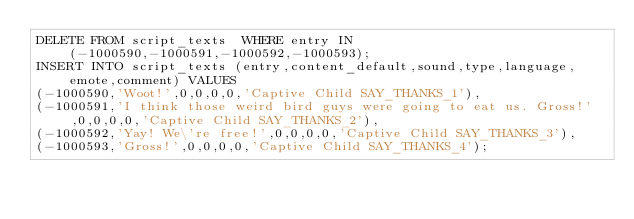Convert code to text. <code><loc_0><loc_0><loc_500><loc_500><_SQL_>DELETE FROM script_texts  WHERE entry IN (-1000590,-1000591,-1000592,-1000593);
INSERT INTO script_texts (entry,content_default,sound,type,language,emote,comment) VALUES
(-1000590,'Woot!',0,0,0,0,'Captive Child SAY_THANKS_1'),
(-1000591,'I think those weird bird guys were going to eat us. Gross!',0,0,0,0,'Captive Child SAY_THANKS_2'),
(-1000592,'Yay! We\'re free!',0,0,0,0,'Captive Child SAY_THANKS_3'),
(-1000593,'Gross!',0,0,0,0,'Captive Child SAY_THANKS_4');
</code> 